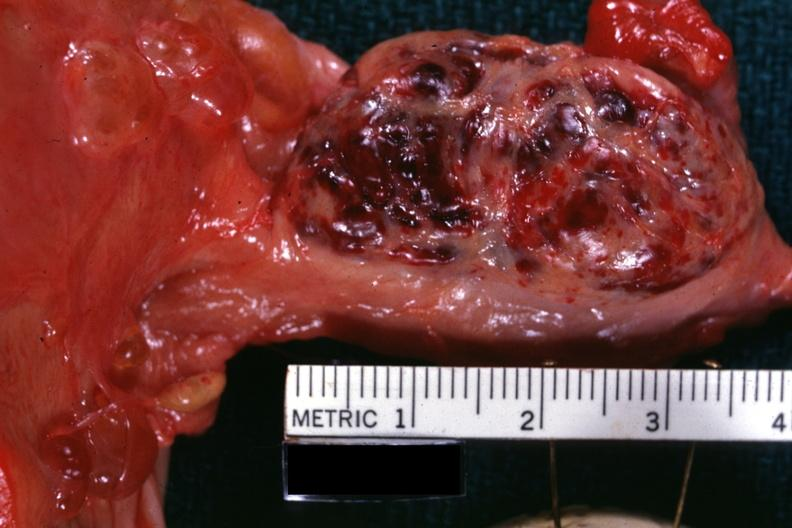what does this image show?
Answer the question using a single word or phrase. Close-up external view of hemorrhagic mass 